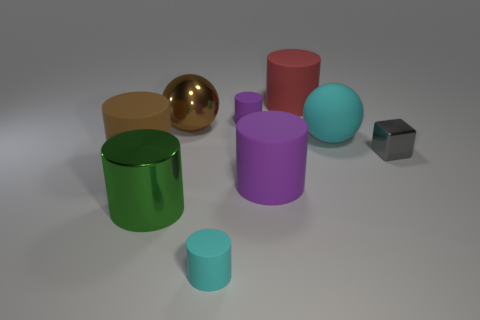Subtract all big green cylinders. How many cylinders are left? 5 Subtract all purple spheres. How many purple cylinders are left? 2 Subtract all cyan cylinders. How many cylinders are left? 5 Subtract all cylinders. How many objects are left? 3 Add 1 gray metallic cylinders. How many objects exist? 10 Subtract 2 cylinders. How many cylinders are left? 4 Add 1 big balls. How many big balls are left? 3 Add 8 large purple rubber cylinders. How many large purple rubber cylinders exist? 9 Subtract 1 cyan cylinders. How many objects are left? 8 Subtract all gray spheres. Subtract all cyan cylinders. How many spheres are left? 2 